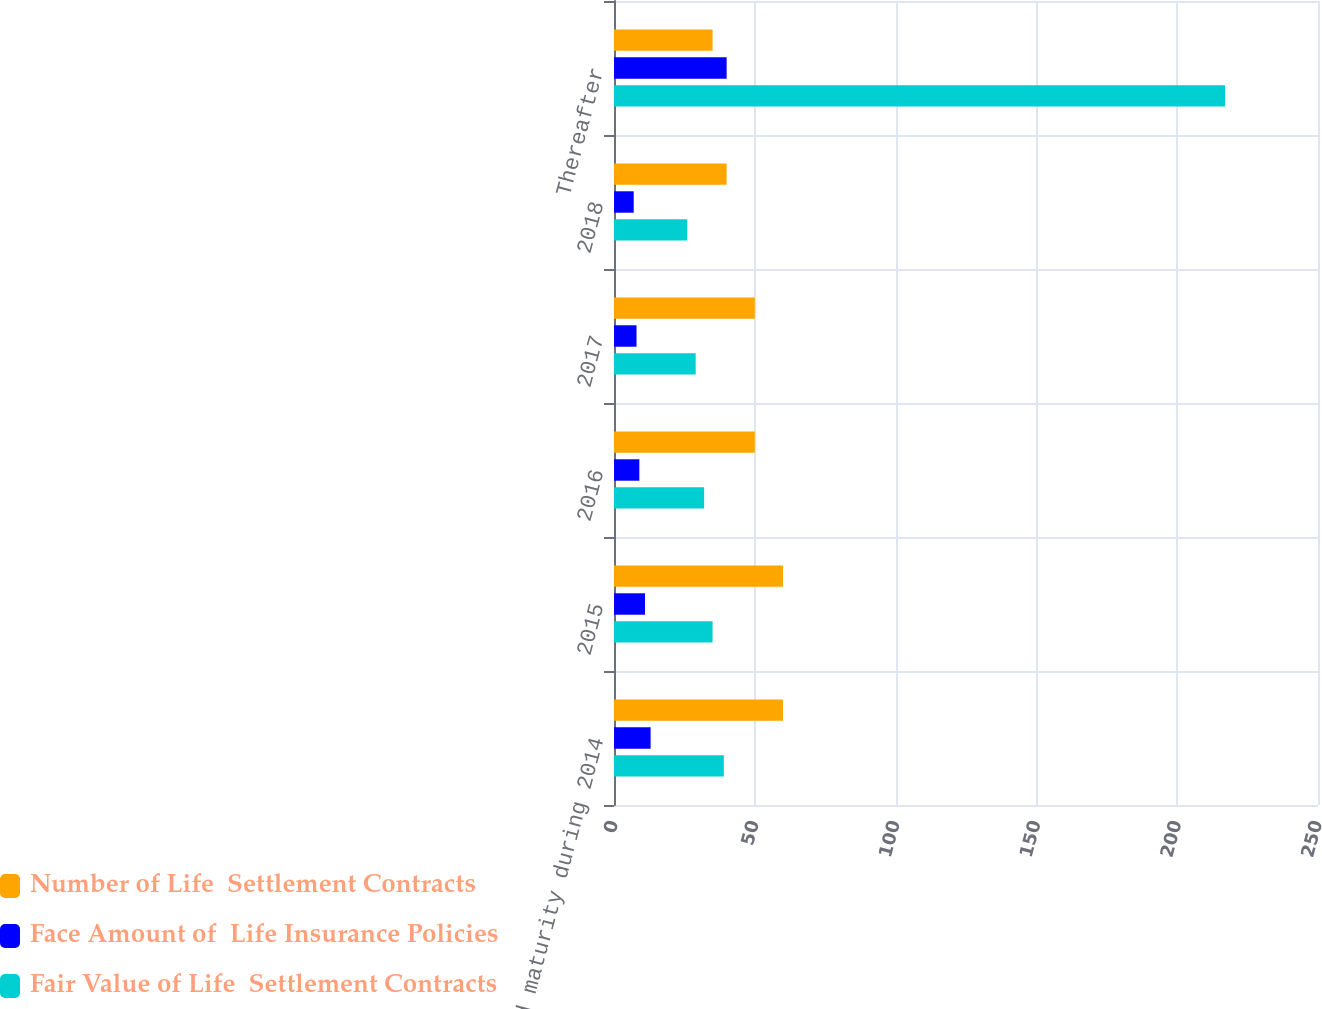Convert chart to OTSL. <chart><loc_0><loc_0><loc_500><loc_500><stacked_bar_chart><ecel><fcel>Estimated maturity during 2014<fcel>2015<fcel>2016<fcel>2017<fcel>2018<fcel>Thereafter<nl><fcel>Number of Life  Settlement Contracts<fcel>60<fcel>60<fcel>50<fcel>50<fcel>40<fcel>35<nl><fcel>Face Amount of  Life Insurance Policies<fcel>13<fcel>11<fcel>9<fcel>8<fcel>7<fcel>40<nl><fcel>Fair Value of Life  Settlement Contracts<fcel>39<fcel>35<fcel>32<fcel>29<fcel>26<fcel>217<nl></chart> 